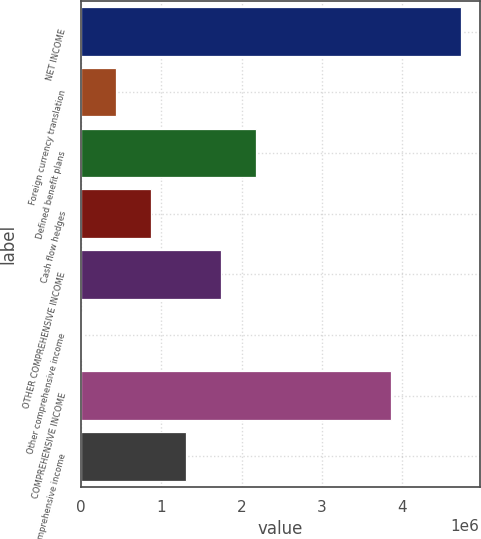Convert chart to OTSL. <chart><loc_0><loc_0><loc_500><loc_500><bar_chart><fcel>NET INCOME<fcel>Foreign currency translation<fcel>Defined benefit plans<fcel>Cash flow hedges<fcel>OTHER COMPREHENSIVE INCOME<fcel>Other comprehensive income<fcel>COMPREHENSIVE INCOME<fcel>Comprehensive income<nl><fcel>4.73049e+06<fcel>442053<fcel>2.17874e+06<fcel>876225<fcel>1.74457e+06<fcel>7881<fcel>3.86214e+06<fcel>1.3104e+06<nl></chart> 